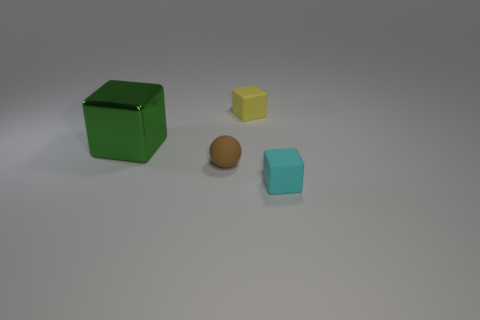What number of other things are there of the same size as the metallic block?
Offer a very short reply. 0. There is a tiny rubber thing in front of the brown matte ball; is its shape the same as the large object?
Give a very brief answer. Yes. Is the number of things in front of the yellow thing greater than the number of rubber things?
Offer a very short reply. No. The object that is both in front of the yellow matte block and behind the tiny sphere is made of what material?
Offer a very short reply. Metal. Is there anything else that is the same shape as the tiny brown rubber object?
Offer a terse response. No. How many cubes are on the left side of the tiny yellow thing and behind the large block?
Your response must be concise. 0. What is the material of the large green cube?
Ensure brevity in your answer.  Metal. Is the number of metallic things right of the tiny yellow matte block the same as the number of green metallic cylinders?
Offer a very short reply. Yes. How many tiny cyan rubber objects are the same shape as the tiny brown rubber thing?
Your answer should be compact. 0. Do the yellow thing and the metallic thing have the same shape?
Make the answer very short. Yes. 